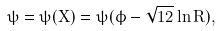Convert formula to latex. <formula><loc_0><loc_0><loc_500><loc_500>\psi = \psi ( X ) = \psi ( \phi - \sqrt { 1 2 } \ln R ) ,</formula> 